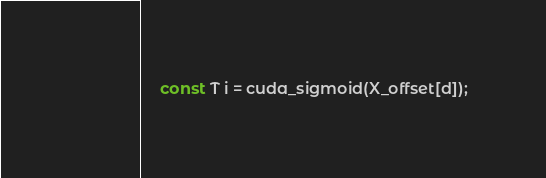Convert code to text. <code><loc_0><loc_0><loc_500><loc_500><_Cuda_>    const T i = cuda_sigmoid(X_offset[d]);</code> 